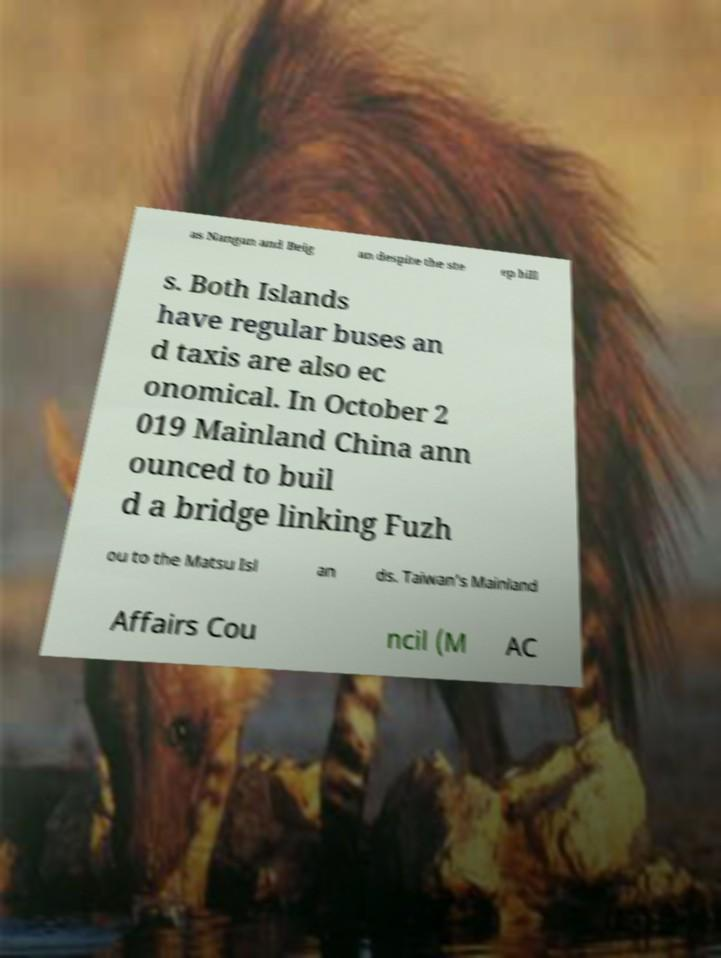There's text embedded in this image that I need extracted. Can you transcribe it verbatim? as Nangan and Beig an despite the ste ep hill s. Both Islands have regular buses an d taxis are also ec onomical. In October 2 019 Mainland China ann ounced to buil d a bridge linking Fuzh ou to the Matsu Isl an ds. Taiwan’s Mainland Affairs Cou ncil (M AC 